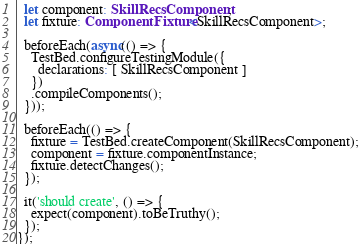Convert code to text. <code><loc_0><loc_0><loc_500><loc_500><_TypeScript_>  let component: SkillRecsComponent;
  let fixture: ComponentFixture<SkillRecsComponent>;

  beforeEach(async(() => {
    TestBed.configureTestingModule({
      declarations: [ SkillRecsComponent ]
    })
    .compileComponents();
  }));

  beforeEach(() => {
    fixture = TestBed.createComponent(SkillRecsComponent);
    component = fixture.componentInstance;
    fixture.detectChanges();
  });

  it('should create', () => {
    expect(component).toBeTruthy();
  });
});
</code> 